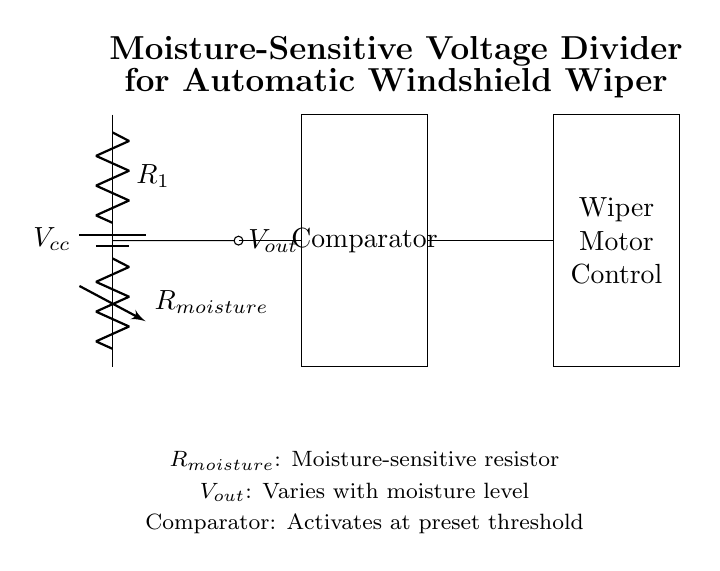What is the role of R1 in this circuit? R1 functions as part of the voltage divider, determining the output voltage in conjunction with R_moisture. The voltage across R1 helps to set the level of output voltage based on the moisture detected.
Answer: Part of voltage divider What does V_out represent? V_out is the output voltage of the moisture-sensitive voltage divider, which varies based on the resistance of the moisture-sensitive resistor. It can indicate the moisture level affecting the wiper's activation.
Answer: Output voltage What activates the windshield wipers? The comparator activates the windshield wipers when V_out reaches a preset moisture threshold, sending a signal to the motor control to start the wipers.
Answer: Comparator What is the purpose of R_moisture? R_moisture is a variable resistor that changes its resistance based on the moisture level, affecting the output voltage of the divider, which in turn helps control the wipers.
Answer: Moisture-sensitive resistor How does moisture affect the output voltage? Increased moisture decreases R_moisture, leading to a higher V_out due to the voltage divider formula. This variation in output voltage is crucial for the comparator to function correctly and activate the windshield wipers.
Answer: Decreases resistance, increases output Which component is responsible for controlling the wiper motor? The wiper motor control component is responsible for activating the windshield wipers based on the signal received from the comparator.
Answer: Wiper Motor Control 